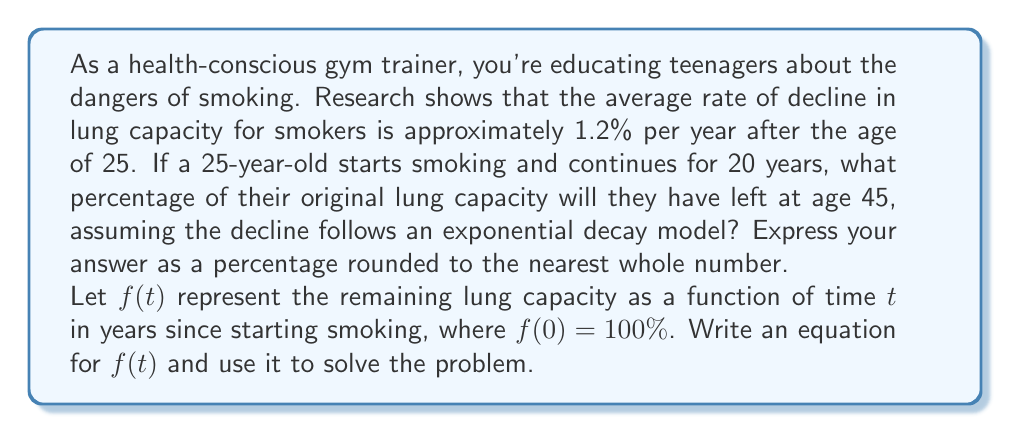Can you solve this math problem? To solve this problem, we'll use an exponential decay model:

1) The general form of exponential decay is:
   $$f(t) = A \cdot (1-r)^t$$
   where $A$ is the initial amount, $r$ is the rate of decay, and $t$ is time.

2) In this case:
   $A = 100\%$ (initial lung capacity)
   $r = 0.012$ (1.2% decline per year)
   $t = 20$ years

3) Our function becomes:
   $$f(t) = 100 \cdot (1-0.012)^t$$

4) To find the remaining lung capacity after 20 years:
   $$f(20) = 100 \cdot (1-0.012)^{20}$$

5) Calculate:
   $$f(20) = 100 \cdot (0.988)^{20}$$
   $$f(20) = 100 \cdot 0.7866...$$
   $$f(20) = 78.66...$$

6) Rounding to the nearest whole percentage:
   $$f(20) \approx 79\%$$

Therefore, after 20 years of smoking, the person will have approximately 79% of their original lung capacity left.
Answer: 79% 